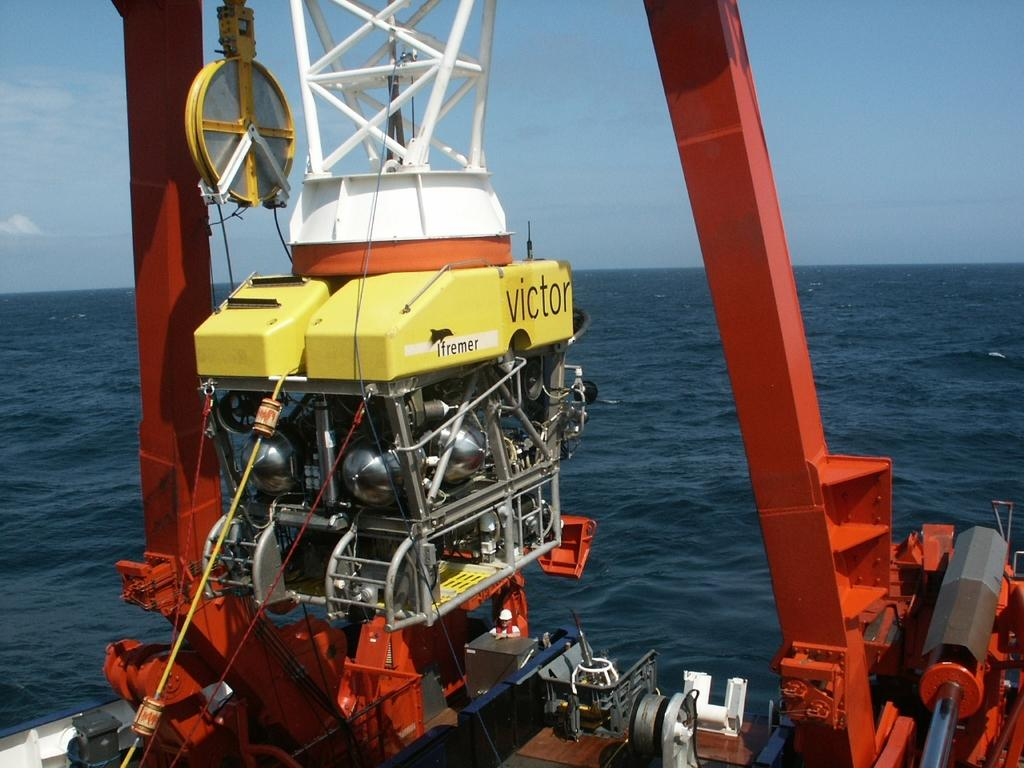What is the main object in the image? There is a machine in the image. What type of material is used for the poles in the image? The poles in the image are made of metal. What structure is present in the image that supports the machine? There is a metal frame in the image that supports the machine. What is tied to the deck in the image? There is a rope on the deck in the image. What can be seen in the background of the image? There is a large water body visible in the image, and the sky appears cloudy. What type of prose is being written on the canvas in the image? There is no canvas or prose present in the image. What type of cloud is depicted in the image? The image does not depict a specific type of cloud; it simply shows a cloudy sky. 